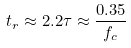<formula> <loc_0><loc_0><loc_500><loc_500>t _ { r } \approx 2 . 2 \tau \approx \frac { 0 . 3 5 } { f _ { c } }</formula> 